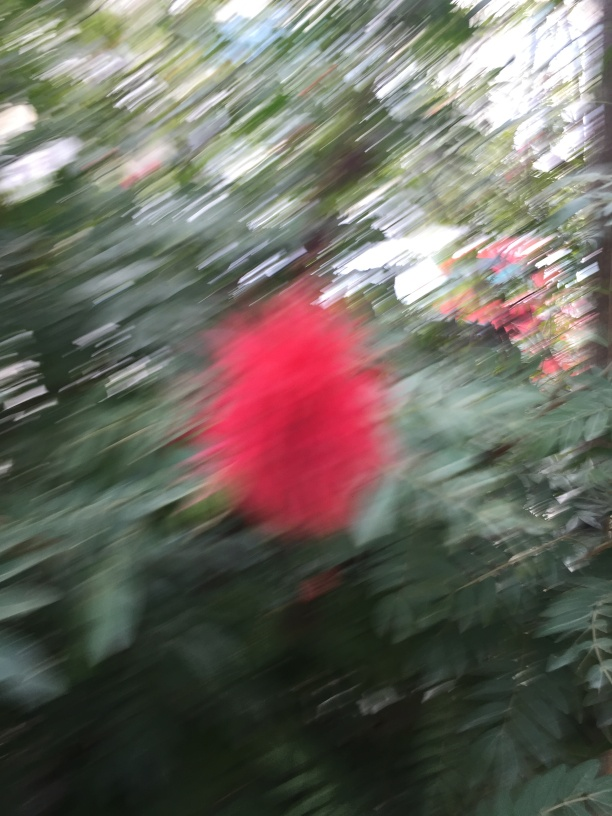Could this image be considered artistic despite the blur? Absolutely, artistic expression is subjective, and a blurred image can convey motion, emotion, or a dreamlike quality that may resonate with viewers. It can suggest a fleeting moment or add a layer of mystery, challenging the audience to interpret the scene. 